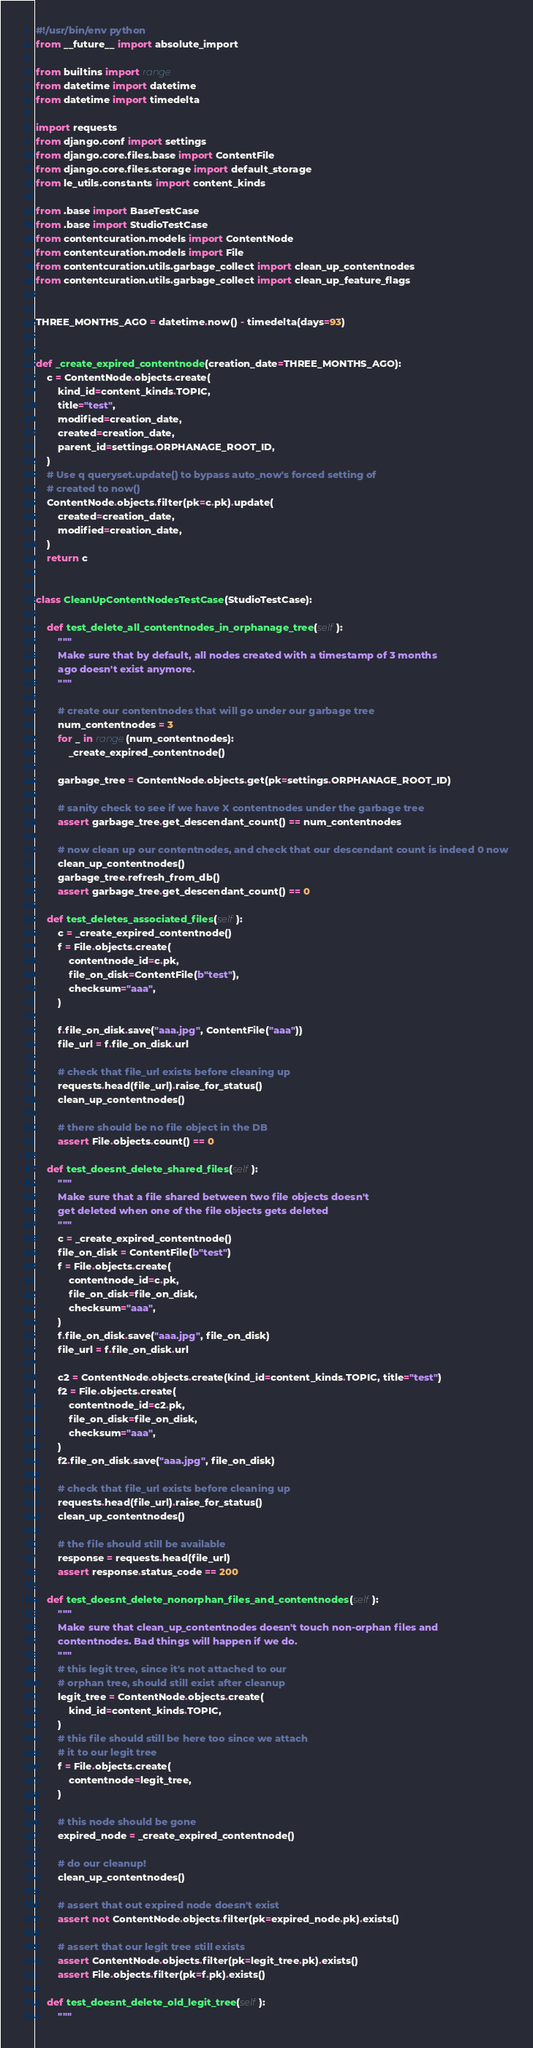Convert code to text. <code><loc_0><loc_0><loc_500><loc_500><_Python_>#!/usr/bin/env python
from __future__ import absolute_import

from builtins import range
from datetime import datetime
from datetime import timedelta

import requests
from django.conf import settings
from django.core.files.base import ContentFile
from django.core.files.storage import default_storage
from le_utils.constants import content_kinds

from .base import BaseTestCase
from .base import StudioTestCase
from contentcuration.models import ContentNode
from contentcuration.models import File
from contentcuration.utils.garbage_collect import clean_up_contentnodes
from contentcuration.utils.garbage_collect import clean_up_feature_flags


THREE_MONTHS_AGO = datetime.now() - timedelta(days=93)


def _create_expired_contentnode(creation_date=THREE_MONTHS_AGO):
    c = ContentNode.objects.create(
        kind_id=content_kinds.TOPIC,
        title="test",
        modified=creation_date,
        created=creation_date,
        parent_id=settings.ORPHANAGE_ROOT_ID,
    )
    # Use q queryset.update() to bypass auto_now's forced setting of
    # created to now()
    ContentNode.objects.filter(pk=c.pk).update(
        created=creation_date,
        modified=creation_date,
    )
    return c


class CleanUpContentNodesTestCase(StudioTestCase):

    def test_delete_all_contentnodes_in_orphanage_tree(self):
        """
        Make sure that by default, all nodes created with a timestamp of 3 months
        ago doesn't exist anymore.
        """

        # create our contentnodes that will go under our garbage tree
        num_contentnodes = 3
        for _ in range(num_contentnodes):
            _create_expired_contentnode()

        garbage_tree = ContentNode.objects.get(pk=settings.ORPHANAGE_ROOT_ID)

        # sanity check to see if we have X contentnodes under the garbage tree
        assert garbage_tree.get_descendant_count() == num_contentnodes

        # now clean up our contentnodes, and check that our descendant count is indeed 0 now
        clean_up_contentnodes()
        garbage_tree.refresh_from_db()
        assert garbage_tree.get_descendant_count() == 0

    def test_deletes_associated_files(self):
        c = _create_expired_contentnode()
        f = File.objects.create(
            contentnode_id=c.pk,
            file_on_disk=ContentFile(b"test"),
            checksum="aaa",
        )

        f.file_on_disk.save("aaa.jpg", ContentFile("aaa"))
        file_url = f.file_on_disk.url

        # check that file_url exists before cleaning up
        requests.head(file_url).raise_for_status()
        clean_up_contentnodes()

        # there should be no file object in the DB
        assert File.objects.count() == 0

    def test_doesnt_delete_shared_files(self):
        """
        Make sure that a file shared between two file objects doesn't
        get deleted when one of the file objects gets deleted
        """
        c = _create_expired_contentnode()
        file_on_disk = ContentFile(b"test")
        f = File.objects.create(
            contentnode_id=c.pk,
            file_on_disk=file_on_disk,
            checksum="aaa",
        )
        f.file_on_disk.save("aaa.jpg", file_on_disk)
        file_url = f.file_on_disk.url

        c2 = ContentNode.objects.create(kind_id=content_kinds.TOPIC, title="test")
        f2 = File.objects.create(
            contentnode_id=c2.pk,
            file_on_disk=file_on_disk,
            checksum="aaa",
        )
        f2.file_on_disk.save("aaa.jpg", file_on_disk)

        # check that file_url exists before cleaning up
        requests.head(file_url).raise_for_status()
        clean_up_contentnodes()

        # the file should still be available
        response = requests.head(file_url)
        assert response.status_code == 200

    def test_doesnt_delete_nonorphan_files_and_contentnodes(self):
        """
        Make sure that clean_up_contentnodes doesn't touch non-orphan files and
        contentnodes. Bad things will happen if we do.
        """
        # this legit tree, since it's not attached to our
        # orphan tree, should still exist after cleanup
        legit_tree = ContentNode.objects.create(
            kind_id=content_kinds.TOPIC,
        )
        # this file should still be here too since we attach
        # it to our legit tree
        f = File.objects.create(
            contentnode=legit_tree,
        )

        # this node should be gone
        expired_node = _create_expired_contentnode()

        # do our cleanup!
        clean_up_contentnodes()

        # assert that out expired node doesn't exist
        assert not ContentNode.objects.filter(pk=expired_node.pk).exists()

        # assert that our legit tree still exists
        assert ContentNode.objects.filter(pk=legit_tree.pk).exists()
        assert File.objects.filter(pk=f.pk).exists()

    def test_doesnt_delete_old_legit_tree(self):
        """</code> 